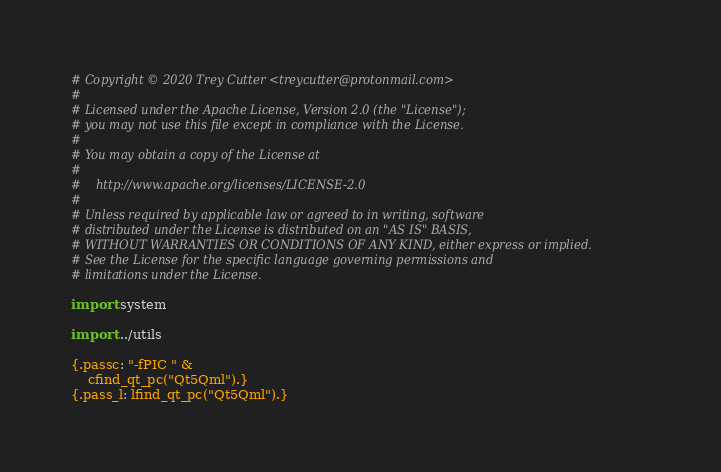Convert code to text. <code><loc_0><loc_0><loc_500><loc_500><_Nim_># Copyright © 2020 Trey Cutter <treycutter@protonmail.com>
#
# Licensed under the Apache License, Version 2.0 (the "License");
# you may not use this file except in compliance with the License.
#
# You may obtain a copy of the License at
#
#    http://www.apache.org/licenses/LICENSE-2.0
#
# Unless required by applicable law or agreed to in writing, software
# distributed under the License is distributed on an "AS IS" BASIS,
# WITHOUT WARRANTIES OR CONDITIONS OF ANY KIND, either express or implied.
# See the License for the specific language governing permissions and
# limitations under the License.

import system

import ../utils

{.passc: "-fPIC " &
    cfind_qt_pc("Qt5Qml").}
{.pass_l: lfind_qt_pc("Qt5Qml").}
</code> 